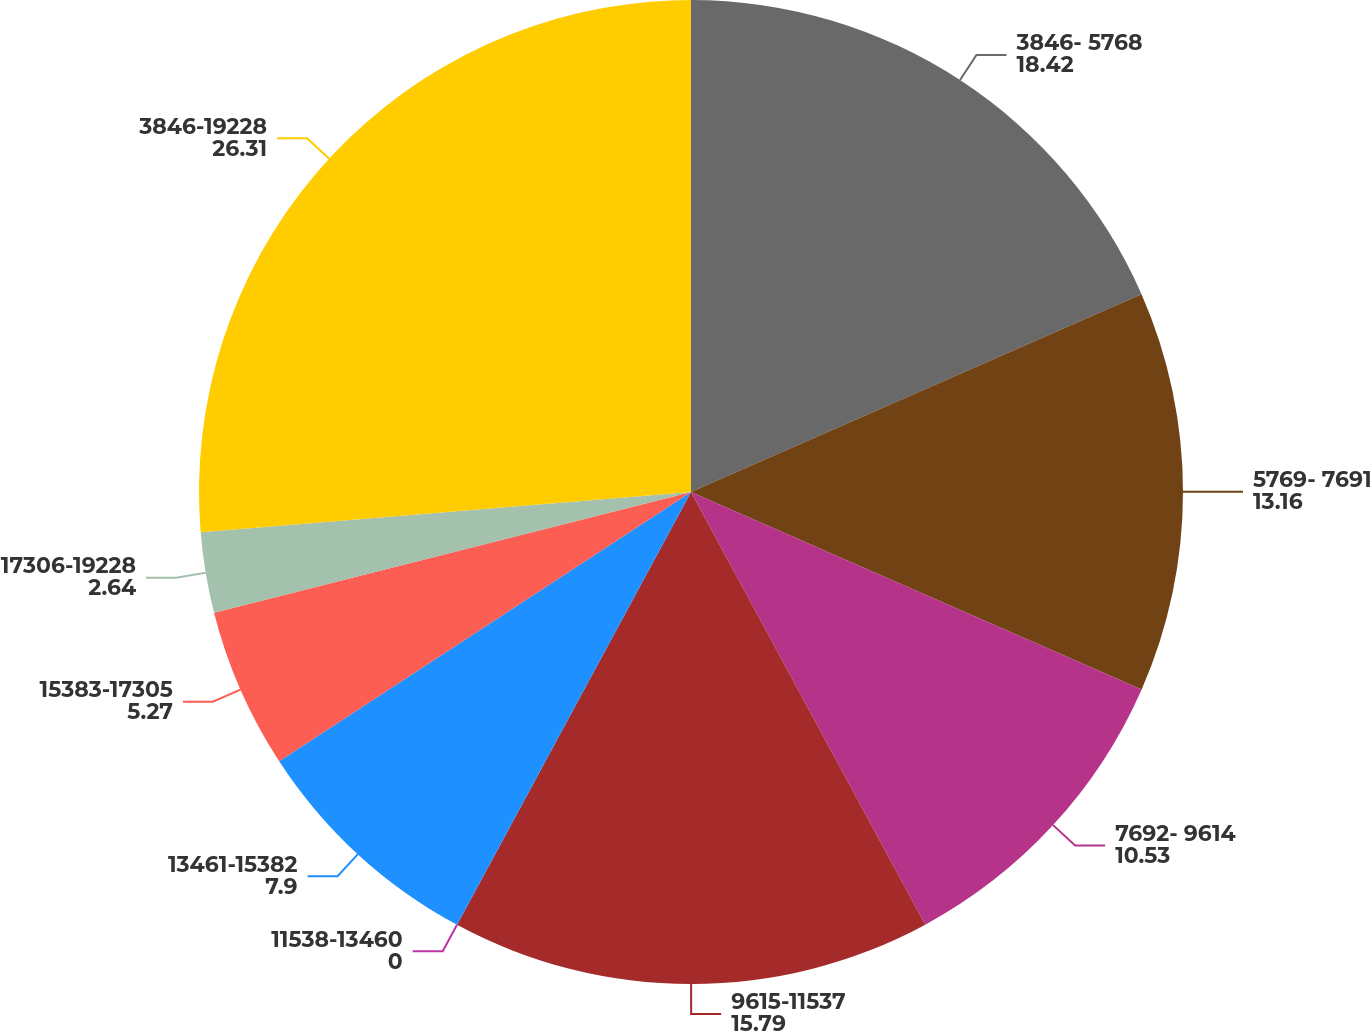Convert chart to OTSL. <chart><loc_0><loc_0><loc_500><loc_500><pie_chart><fcel>3846- 5768<fcel>5769- 7691<fcel>7692- 9614<fcel>9615-11537<fcel>11538-13460<fcel>13461-15382<fcel>15383-17305<fcel>17306-19228<fcel>3846-19228<nl><fcel>18.42%<fcel>13.16%<fcel>10.53%<fcel>15.79%<fcel>0.0%<fcel>7.9%<fcel>5.27%<fcel>2.64%<fcel>26.31%<nl></chart> 